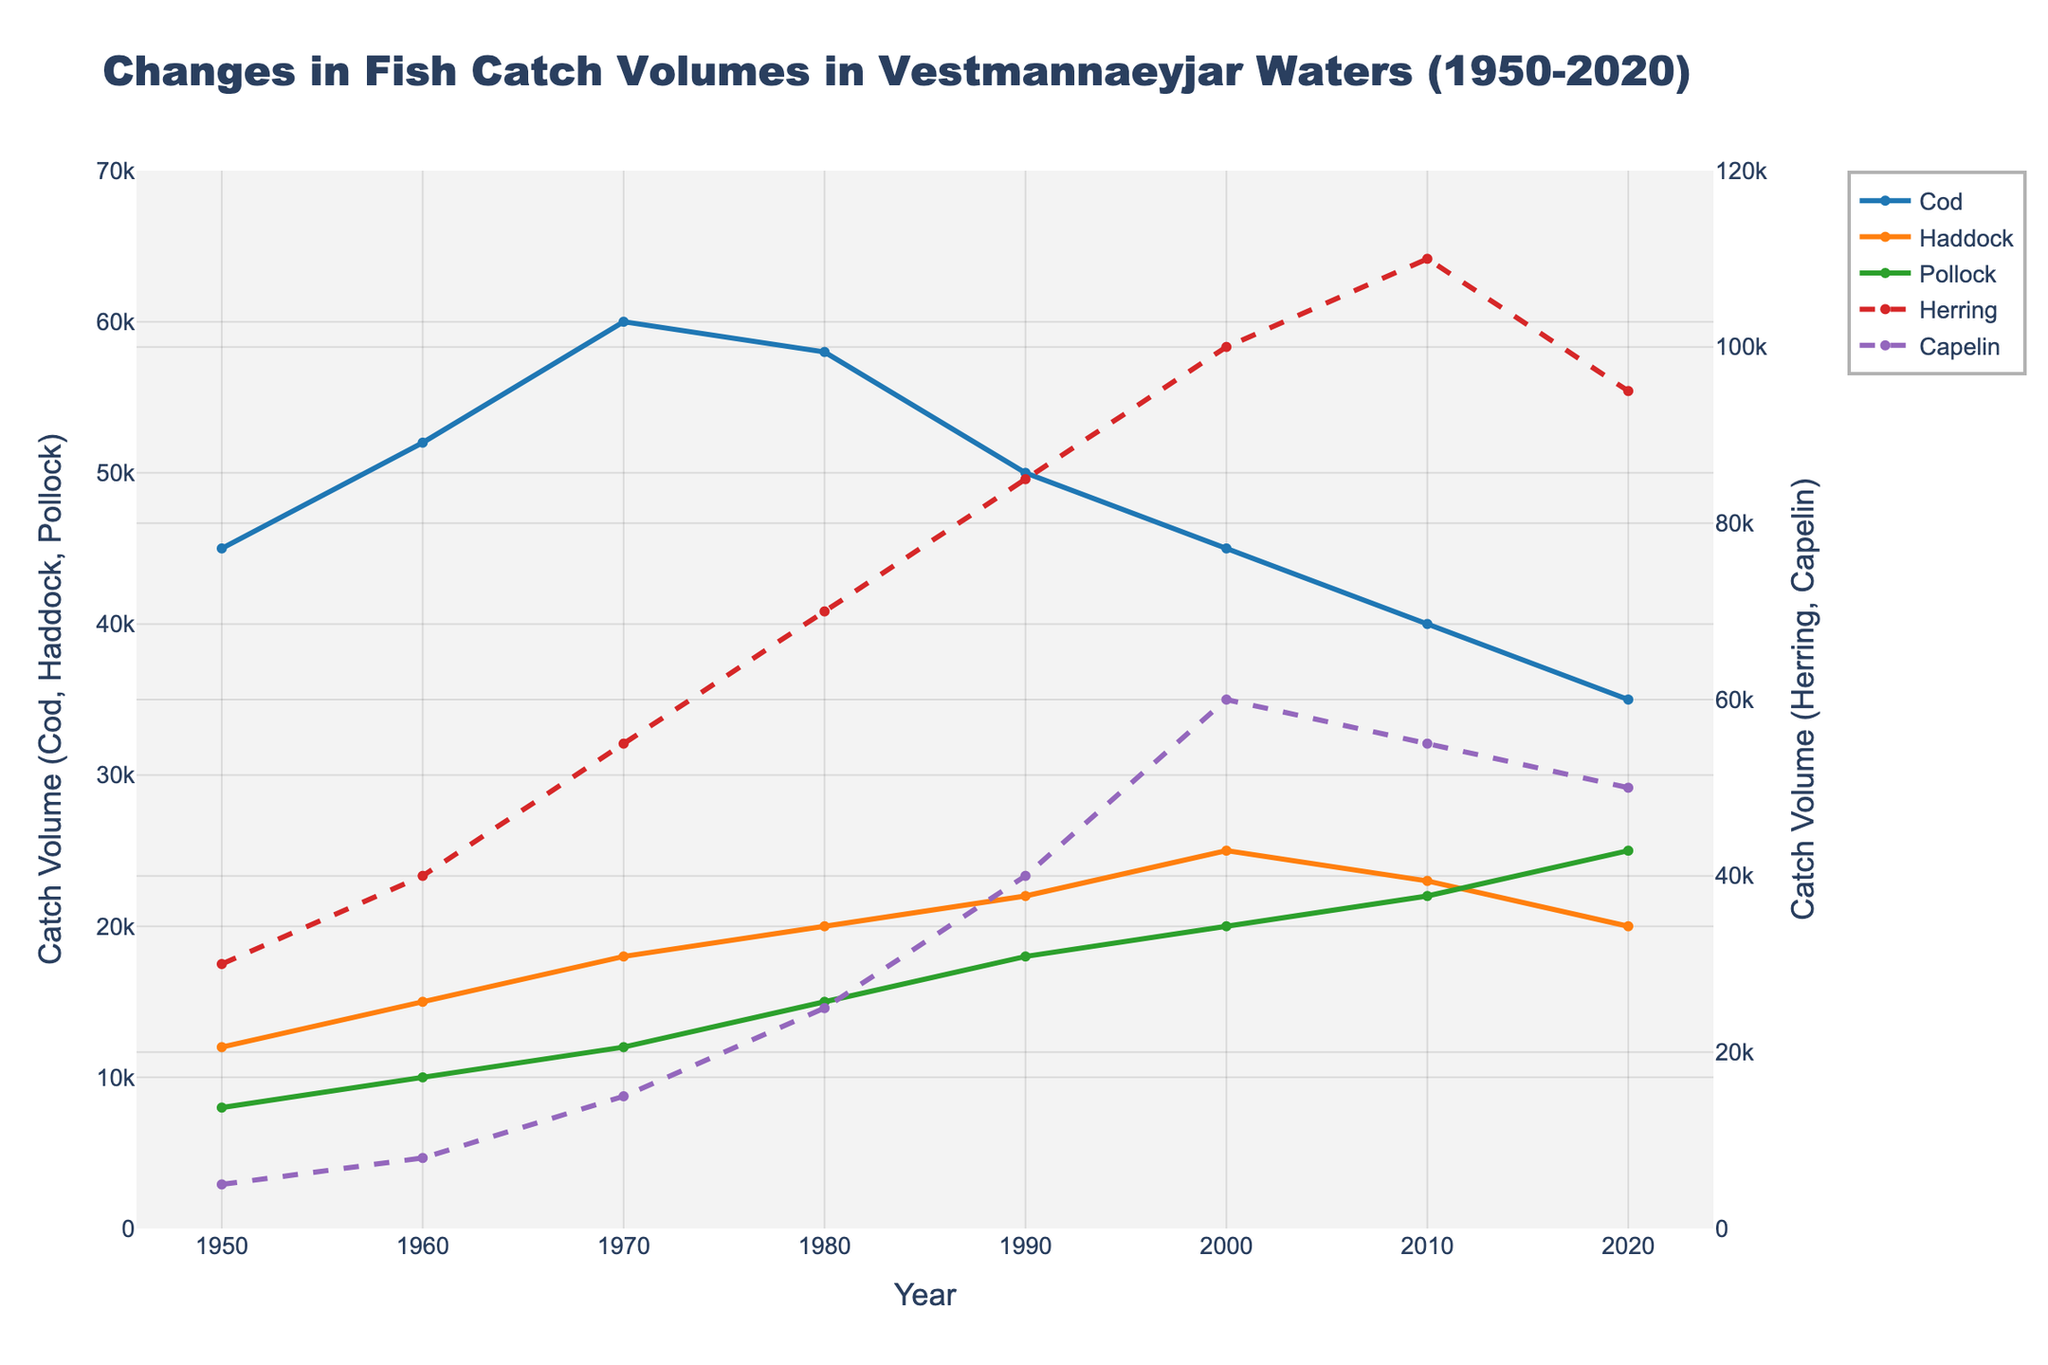What are the catch volumes for Cod and Haddock in 1970? From the plot, the catch volume for Cod in 1970 is 60,000 and for Haddock in 1970 is 18,000.
Answer: Cod: 60,000, Haddock: 18,000 In which year did Haddock have the highest catch volume, and what was it? From the plot, the highest catch volume for Haddock was in the year 2000 with a volume of 25,000.
Answer: Year 2000, 25,000 How does the trend of Herring catch volumes compare to Capelin catch volumes from 1980 to 2020? Both Herring and Capelin show an upward trend from 1980 to 2000. After 2000, Herring continues to increase, reaching a peak in 2010, while Capelin shows a decline after 2000.
Answer: Herring increases steadily, Capelin declines after 2000 What is the difference in catch volumes between Cod and Pollock in 2020? From the plot, the catch volume for Cod in 2020 is 35,000 and for Pollock, it is 25,000. The difference is 35,000 - 25,000 = 10,000.
Answer: 10,000 What visual pattern do the Herring catch volumes form? Herring catch volumes form a dashed red line that increases significantly from 1950 to 2010 and shows a slight decrease in 2020.
Answer: Dashed red line, increasing How many years did Haddock's catch volume remain between 20,000 and 25,000? From the plot, Haddock's catch volumes between 20,000 and 25,000 are observed in the years 1980, 1990, and 2000, which are 3 years.
Answer: 3 years What is the sum of Capelin catch volumes in 2000 and 2010? From the plot, the catch volumes for Capelin in 2000 and 2010 are 60,000 and 55,000, respectively. The sum is 60,000 + 55,000 = 115,000.
Answer: 115,000 Which species had the highest catch volume in 2010 and what was it? From the plot, Herring had the highest catch volume in 2010 with a volume of 110,000.
Answer: Herring, 110,000 